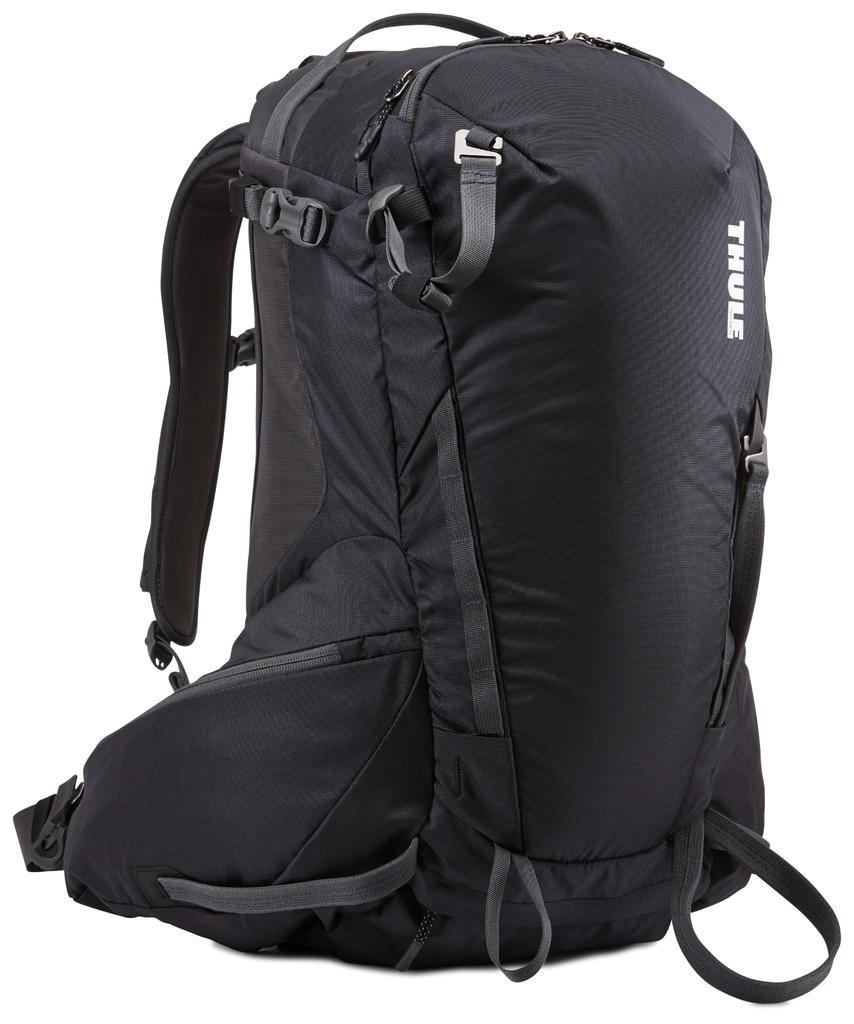Describe this image in one or two sentences. It is a black color bag with lot of zips there is a name written as 'THUE' on it the background is white color. 